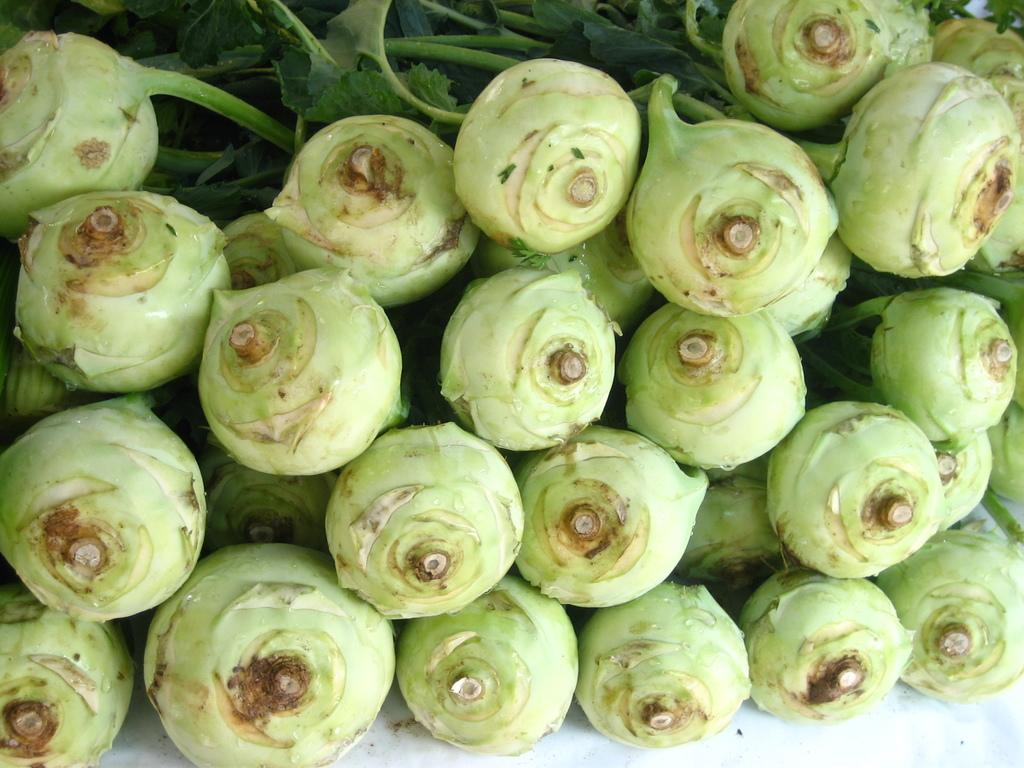What type of food can be seen in the image? There are vegetables in the image. What color is the surface where the vegetables are placed? The surface the vegetables are on is white. What type of zephyr can be smelled in the image? There is no mention of a zephyr or any scent in the image, as it only features vegetables on a white surface. 